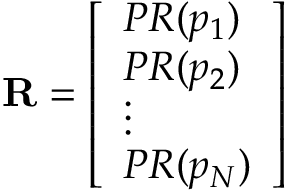Convert formula to latex. <formula><loc_0><loc_0><loc_500><loc_500>R = { \left [ \begin{array} { l } { P R ( p _ { 1 } ) } \\ { P R ( p _ { 2 } ) } \\ { \vdots } \\ { P R ( p _ { N } ) } \end{array} \right ] }</formula> 